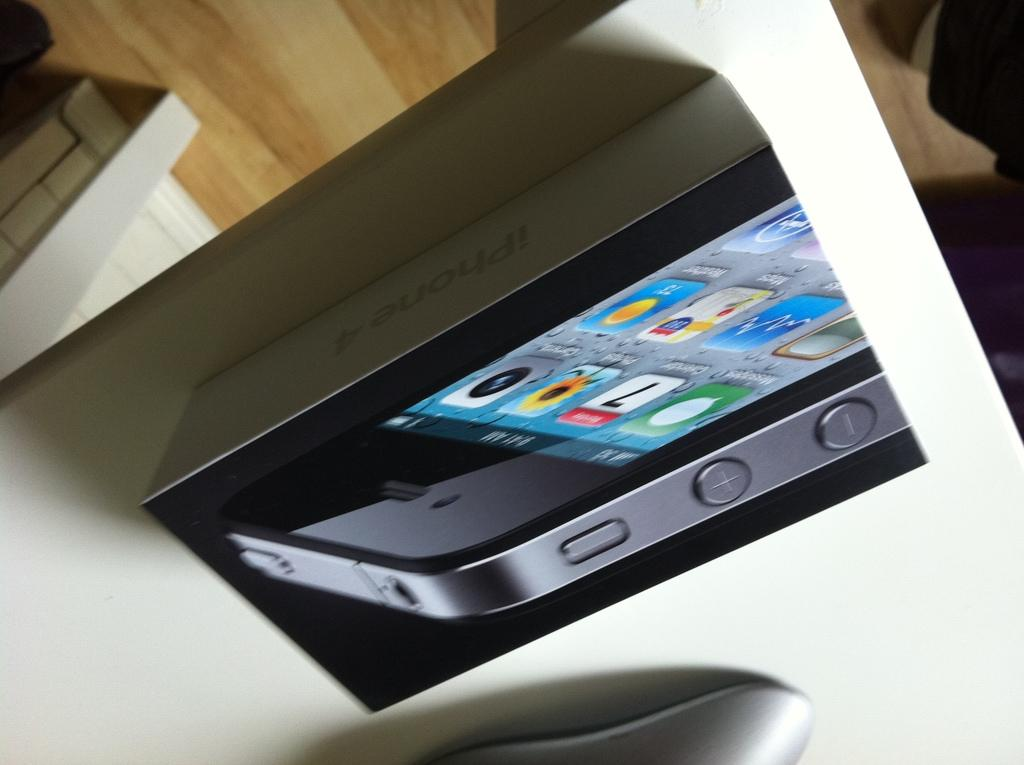<image>
Write a terse but informative summary of the picture. A box with a picture of Iphone 4 is laying on a table with a mouse next ot it. 